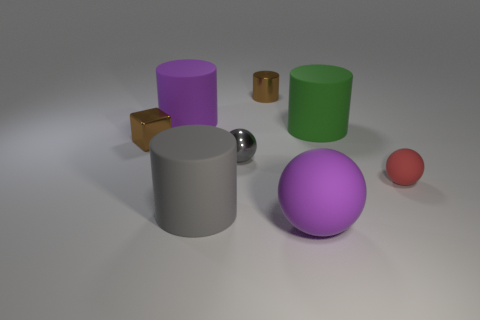What material is the large thing that is the same shape as the small gray object?
Provide a succinct answer. Rubber. Does the large purple matte thing in front of the brown cube have the same shape as the gray metal thing that is in front of the small shiny cylinder?
Your answer should be compact. Yes. Are there more small gray metal spheres than tiny brown matte spheres?
Your answer should be very brief. Yes. What size is the gray metallic ball?
Your answer should be compact. Small. How many other things are there of the same color as the metallic ball?
Provide a short and direct response. 1. Does the brown thing that is in front of the green cylinder have the same material as the big green cylinder?
Make the answer very short. No. Is the number of big things that are in front of the green cylinder less than the number of objects that are behind the gray matte thing?
Make the answer very short. Yes. What number of other objects are the same material as the red ball?
Give a very brief answer. 4. What is the material of the red thing that is the same size as the cube?
Provide a succinct answer. Rubber. Is the number of tiny brown cubes that are on the right side of the small gray ball less than the number of purple spheres?
Your answer should be very brief. Yes. 